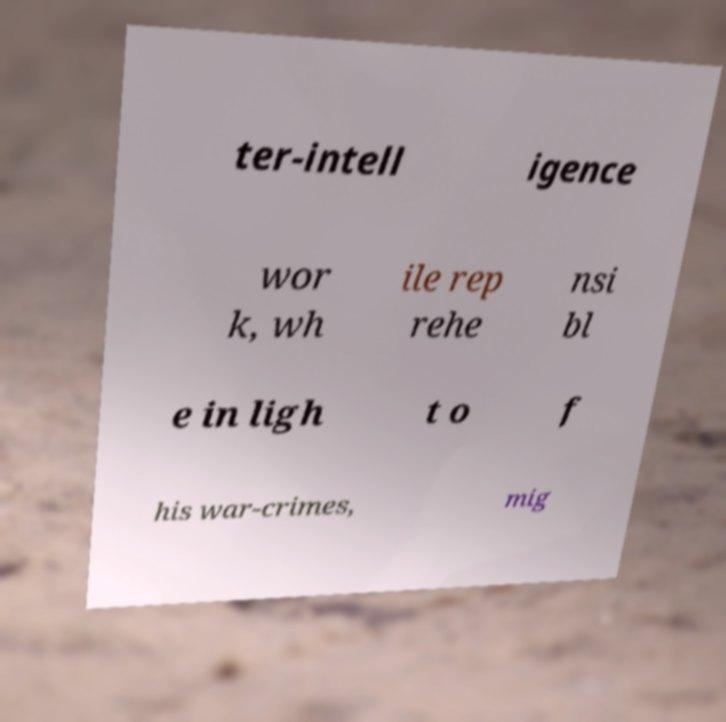For documentation purposes, I need the text within this image transcribed. Could you provide that? ter-intell igence wor k, wh ile rep rehe nsi bl e in ligh t o f his war-crimes, mig 